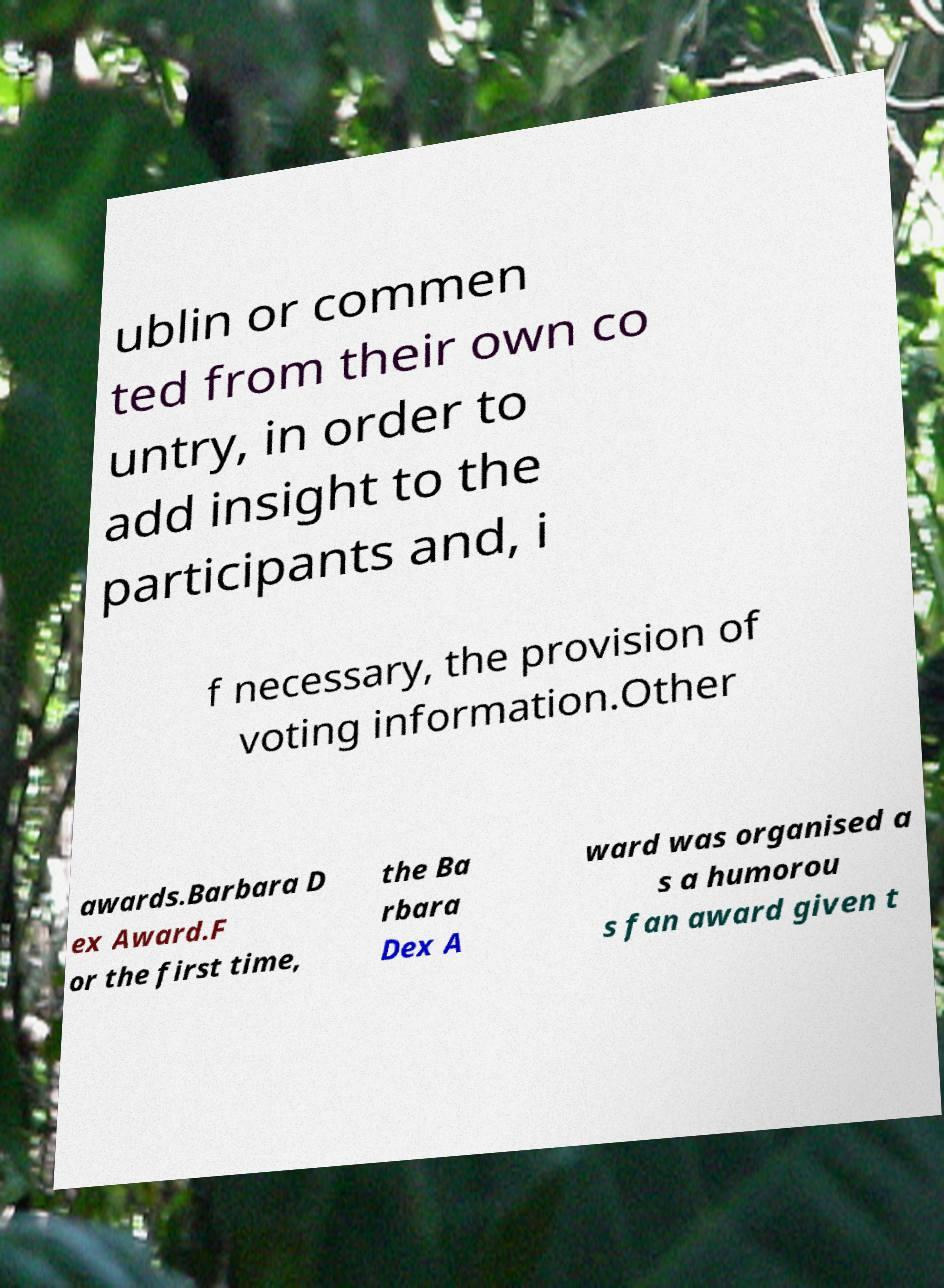What messages or text are displayed in this image? I need them in a readable, typed format. ublin or commen ted from their own co untry, in order to add insight to the participants and, i f necessary, the provision of voting information.Other awards.Barbara D ex Award.F or the first time, the Ba rbara Dex A ward was organised a s a humorou s fan award given t 